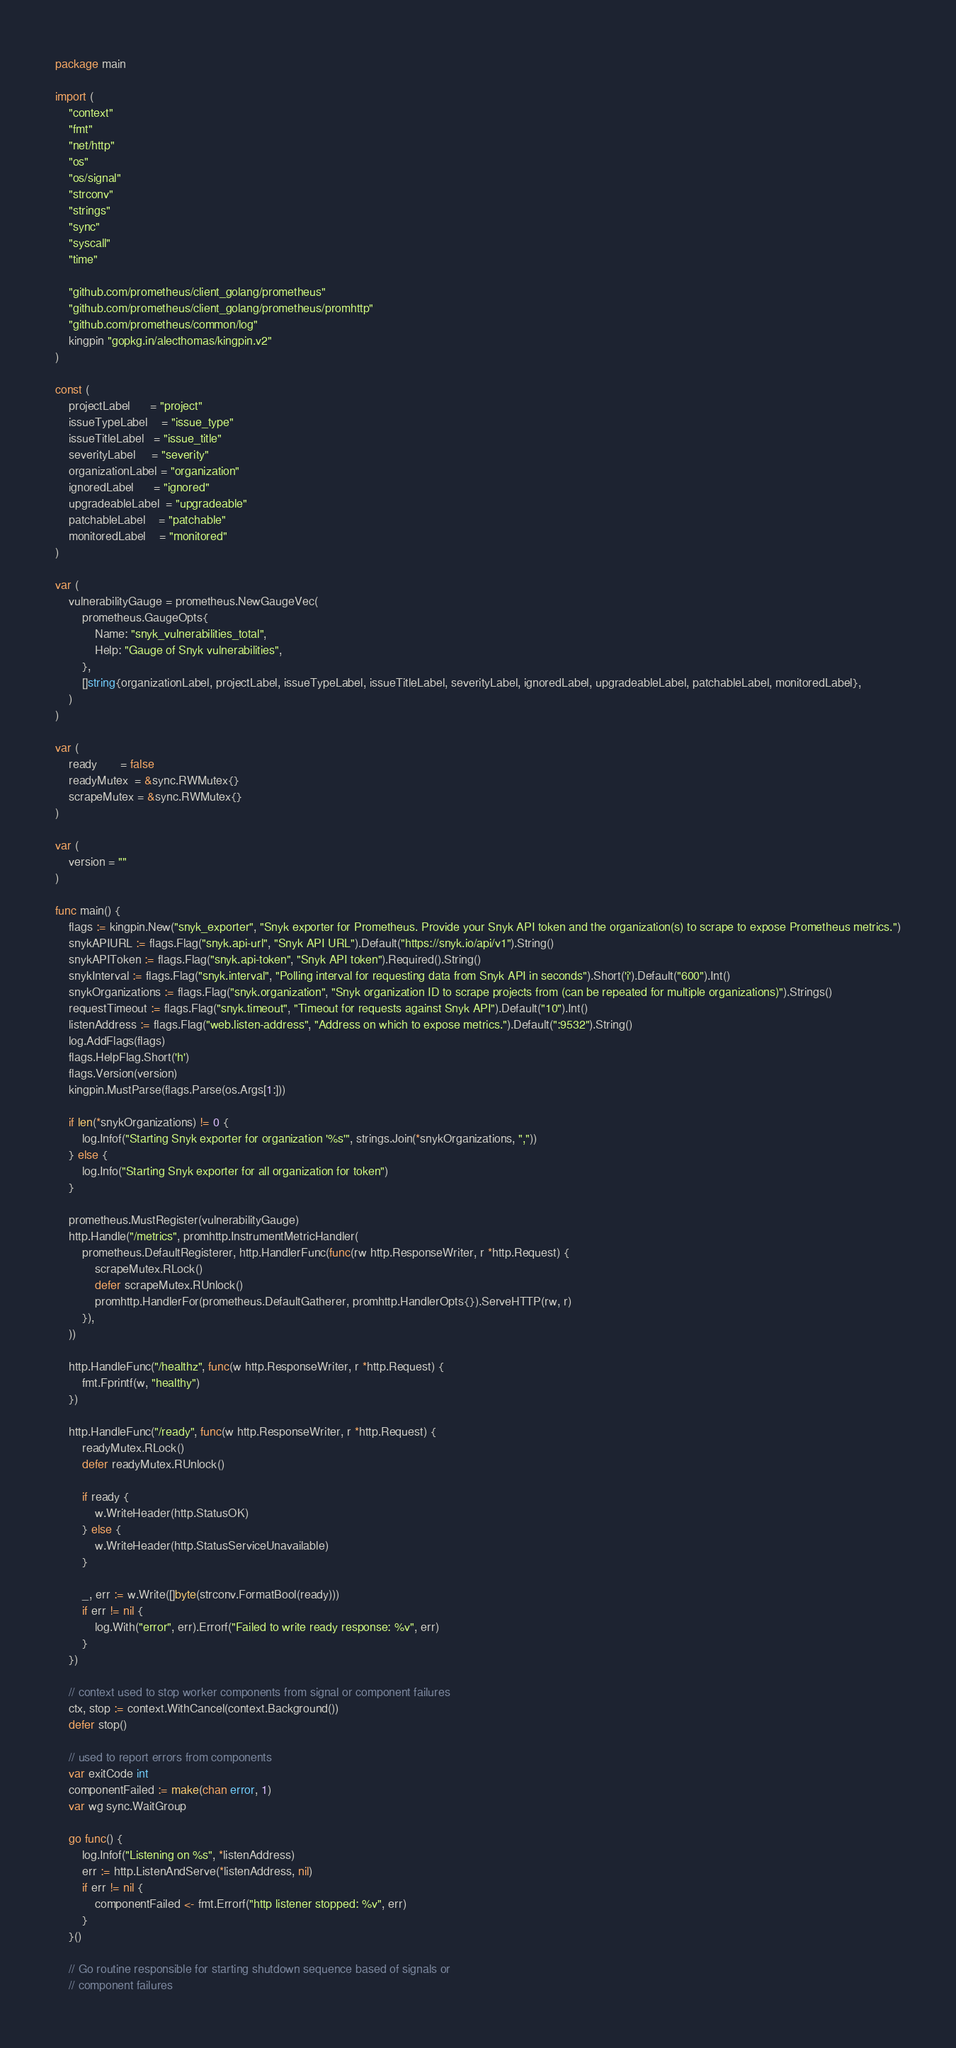Convert code to text. <code><loc_0><loc_0><loc_500><loc_500><_Go_>package main

import (
	"context"
	"fmt"
	"net/http"
	"os"
	"os/signal"
	"strconv"
	"strings"
	"sync"
	"syscall"
	"time"

	"github.com/prometheus/client_golang/prometheus"
	"github.com/prometheus/client_golang/prometheus/promhttp"
	"github.com/prometheus/common/log"
	kingpin "gopkg.in/alecthomas/kingpin.v2"
)

const (
	projectLabel      = "project"
	issueTypeLabel    = "issue_type"
	issueTitleLabel   = "issue_title"
	severityLabel     = "severity"
	organizationLabel = "organization"
	ignoredLabel      = "ignored"
	upgradeableLabel  = "upgradeable"
	patchableLabel    = "patchable"
	monitoredLabel    = "monitored"
)

var (
	vulnerabilityGauge = prometheus.NewGaugeVec(
		prometheus.GaugeOpts{
			Name: "snyk_vulnerabilities_total",
			Help: "Gauge of Snyk vulnerabilities",
		},
		[]string{organizationLabel, projectLabel, issueTypeLabel, issueTitleLabel, severityLabel, ignoredLabel, upgradeableLabel, patchableLabel, monitoredLabel},
	)
)

var (
	ready       = false
	readyMutex  = &sync.RWMutex{}
	scrapeMutex = &sync.RWMutex{}
)

var (
	version = ""
)

func main() {
	flags := kingpin.New("snyk_exporter", "Snyk exporter for Prometheus. Provide your Snyk API token and the organization(s) to scrape to expose Prometheus metrics.")
	snykAPIURL := flags.Flag("snyk.api-url", "Snyk API URL").Default("https://snyk.io/api/v1").String()
	snykAPIToken := flags.Flag("snyk.api-token", "Snyk API token").Required().String()
	snykInterval := flags.Flag("snyk.interval", "Polling interval for requesting data from Snyk API in seconds").Short('i').Default("600").Int()
	snykOrganizations := flags.Flag("snyk.organization", "Snyk organization ID to scrape projects from (can be repeated for multiple organizations)").Strings()
	requestTimeout := flags.Flag("snyk.timeout", "Timeout for requests against Snyk API").Default("10").Int()
	listenAddress := flags.Flag("web.listen-address", "Address on which to expose metrics.").Default(":9532").String()
	log.AddFlags(flags)
	flags.HelpFlag.Short('h')
	flags.Version(version)
	kingpin.MustParse(flags.Parse(os.Args[1:]))

	if len(*snykOrganizations) != 0 {
		log.Infof("Starting Snyk exporter for organization '%s'", strings.Join(*snykOrganizations, ","))
	} else {
		log.Info("Starting Snyk exporter for all organization for token")
	}

	prometheus.MustRegister(vulnerabilityGauge)
	http.Handle("/metrics", promhttp.InstrumentMetricHandler(
		prometheus.DefaultRegisterer, http.HandlerFunc(func(rw http.ResponseWriter, r *http.Request) {
			scrapeMutex.RLock()
			defer scrapeMutex.RUnlock()
			promhttp.HandlerFor(prometheus.DefaultGatherer, promhttp.HandlerOpts{}).ServeHTTP(rw, r)
		}),
	))

	http.HandleFunc("/healthz", func(w http.ResponseWriter, r *http.Request) {
		fmt.Fprintf(w, "healthy")
	})

	http.HandleFunc("/ready", func(w http.ResponseWriter, r *http.Request) {
		readyMutex.RLock()
		defer readyMutex.RUnlock()

		if ready {
			w.WriteHeader(http.StatusOK)
		} else {
			w.WriteHeader(http.StatusServiceUnavailable)
		}

		_, err := w.Write([]byte(strconv.FormatBool(ready)))
		if err != nil {
			log.With("error", err).Errorf("Failed to write ready response: %v", err)
		}
	})

	// context used to stop worker components from signal or component failures
	ctx, stop := context.WithCancel(context.Background())
	defer stop()

	// used to report errors from components
	var exitCode int
	componentFailed := make(chan error, 1)
	var wg sync.WaitGroup

	go func() {
		log.Infof("Listening on %s", *listenAddress)
		err := http.ListenAndServe(*listenAddress, nil)
		if err != nil {
			componentFailed <- fmt.Errorf("http listener stopped: %v", err)
		}
	}()

	// Go routine responsible for starting shutdown sequence based of signals or
	// component failures</code> 